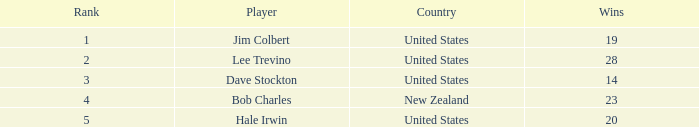How many average wins for players ranked below 2 with earnings greater than $7,676,552? None. 